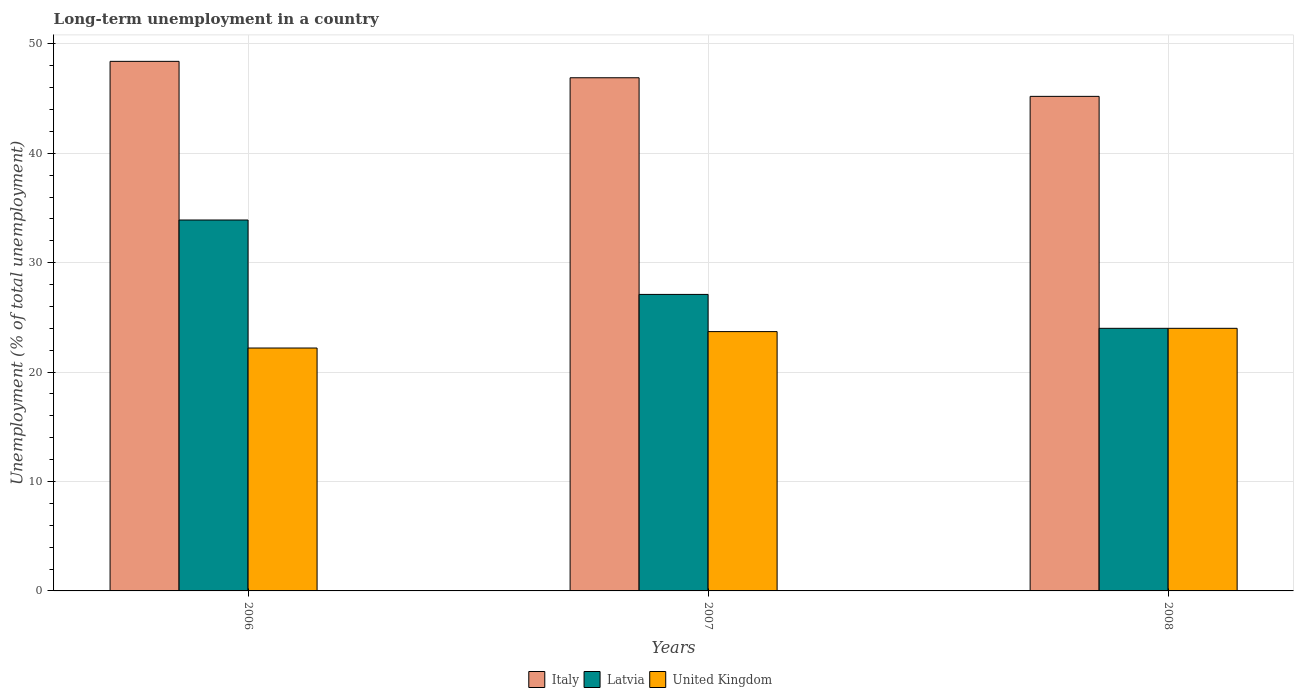How many different coloured bars are there?
Provide a short and direct response. 3. Are the number of bars on each tick of the X-axis equal?
Give a very brief answer. Yes. How many bars are there on the 2nd tick from the left?
Keep it short and to the point. 3. What is the percentage of long-term unemployed population in United Kingdom in 2006?
Provide a short and direct response. 22.2. Across all years, what is the maximum percentage of long-term unemployed population in Latvia?
Give a very brief answer. 33.9. Across all years, what is the minimum percentage of long-term unemployed population in Italy?
Ensure brevity in your answer.  45.2. In which year was the percentage of long-term unemployed population in Italy maximum?
Keep it short and to the point. 2006. What is the total percentage of long-term unemployed population in United Kingdom in the graph?
Keep it short and to the point. 69.9. What is the difference between the percentage of long-term unemployed population in Latvia in 2007 and that in 2008?
Provide a succinct answer. 3.1. What is the difference between the percentage of long-term unemployed population in United Kingdom in 2008 and the percentage of long-term unemployed population in Latvia in 2006?
Your answer should be very brief. -9.9. What is the average percentage of long-term unemployed population in United Kingdom per year?
Ensure brevity in your answer.  23.3. In the year 2008, what is the difference between the percentage of long-term unemployed population in Latvia and percentage of long-term unemployed population in United Kingdom?
Provide a short and direct response. 0. In how many years, is the percentage of long-term unemployed population in Latvia greater than 48 %?
Offer a terse response. 0. What is the ratio of the percentage of long-term unemployed population in Latvia in 2006 to that in 2008?
Provide a succinct answer. 1.41. Is the difference between the percentage of long-term unemployed population in Latvia in 2006 and 2008 greater than the difference between the percentage of long-term unemployed population in United Kingdom in 2006 and 2008?
Your answer should be very brief. Yes. What is the difference between the highest and the second highest percentage of long-term unemployed population in Italy?
Your answer should be compact. 1.5. What is the difference between the highest and the lowest percentage of long-term unemployed population in Italy?
Your answer should be compact. 3.2. In how many years, is the percentage of long-term unemployed population in United Kingdom greater than the average percentage of long-term unemployed population in United Kingdom taken over all years?
Give a very brief answer. 2. Is the sum of the percentage of long-term unemployed population in Italy in 2007 and 2008 greater than the maximum percentage of long-term unemployed population in Latvia across all years?
Ensure brevity in your answer.  Yes. What does the 3rd bar from the left in 2007 represents?
Your answer should be compact. United Kingdom. What does the 3rd bar from the right in 2006 represents?
Offer a terse response. Italy. Is it the case that in every year, the sum of the percentage of long-term unemployed population in Latvia and percentage of long-term unemployed population in Italy is greater than the percentage of long-term unemployed population in United Kingdom?
Your response must be concise. Yes. How many bars are there?
Give a very brief answer. 9. Are all the bars in the graph horizontal?
Keep it short and to the point. No. How many years are there in the graph?
Ensure brevity in your answer.  3. What is the difference between two consecutive major ticks on the Y-axis?
Give a very brief answer. 10. Are the values on the major ticks of Y-axis written in scientific E-notation?
Provide a short and direct response. No. Does the graph contain any zero values?
Your answer should be very brief. No. Does the graph contain grids?
Offer a very short reply. Yes. Where does the legend appear in the graph?
Provide a succinct answer. Bottom center. How are the legend labels stacked?
Your answer should be very brief. Horizontal. What is the title of the graph?
Offer a very short reply. Long-term unemployment in a country. Does "Angola" appear as one of the legend labels in the graph?
Make the answer very short. No. What is the label or title of the Y-axis?
Make the answer very short. Unemployment (% of total unemployment). What is the Unemployment (% of total unemployment) in Italy in 2006?
Ensure brevity in your answer.  48.4. What is the Unemployment (% of total unemployment) in Latvia in 2006?
Give a very brief answer. 33.9. What is the Unemployment (% of total unemployment) of United Kingdom in 2006?
Provide a short and direct response. 22.2. What is the Unemployment (% of total unemployment) in Italy in 2007?
Offer a terse response. 46.9. What is the Unemployment (% of total unemployment) of Latvia in 2007?
Provide a short and direct response. 27.1. What is the Unemployment (% of total unemployment) in United Kingdom in 2007?
Make the answer very short. 23.7. What is the Unemployment (% of total unemployment) in Italy in 2008?
Your answer should be very brief. 45.2. What is the Unemployment (% of total unemployment) in Latvia in 2008?
Your response must be concise. 24. Across all years, what is the maximum Unemployment (% of total unemployment) in Italy?
Ensure brevity in your answer.  48.4. Across all years, what is the maximum Unemployment (% of total unemployment) of Latvia?
Provide a short and direct response. 33.9. Across all years, what is the maximum Unemployment (% of total unemployment) of United Kingdom?
Your answer should be very brief. 24. Across all years, what is the minimum Unemployment (% of total unemployment) of Italy?
Offer a very short reply. 45.2. Across all years, what is the minimum Unemployment (% of total unemployment) of Latvia?
Give a very brief answer. 24. Across all years, what is the minimum Unemployment (% of total unemployment) in United Kingdom?
Provide a succinct answer. 22.2. What is the total Unemployment (% of total unemployment) in Italy in the graph?
Offer a terse response. 140.5. What is the total Unemployment (% of total unemployment) of Latvia in the graph?
Your answer should be very brief. 85. What is the total Unemployment (% of total unemployment) in United Kingdom in the graph?
Make the answer very short. 69.9. What is the difference between the Unemployment (% of total unemployment) in Italy in 2006 and that in 2007?
Ensure brevity in your answer.  1.5. What is the difference between the Unemployment (% of total unemployment) in Latvia in 2006 and that in 2007?
Your answer should be compact. 6.8. What is the difference between the Unemployment (% of total unemployment) of Italy in 2006 and that in 2008?
Provide a short and direct response. 3.2. What is the difference between the Unemployment (% of total unemployment) in United Kingdom in 2006 and that in 2008?
Make the answer very short. -1.8. What is the difference between the Unemployment (% of total unemployment) in United Kingdom in 2007 and that in 2008?
Offer a very short reply. -0.3. What is the difference between the Unemployment (% of total unemployment) of Italy in 2006 and the Unemployment (% of total unemployment) of Latvia in 2007?
Give a very brief answer. 21.3. What is the difference between the Unemployment (% of total unemployment) in Italy in 2006 and the Unemployment (% of total unemployment) in United Kingdom in 2007?
Give a very brief answer. 24.7. What is the difference between the Unemployment (% of total unemployment) in Italy in 2006 and the Unemployment (% of total unemployment) in Latvia in 2008?
Offer a terse response. 24.4. What is the difference between the Unemployment (% of total unemployment) in Italy in 2006 and the Unemployment (% of total unemployment) in United Kingdom in 2008?
Give a very brief answer. 24.4. What is the difference between the Unemployment (% of total unemployment) in Latvia in 2006 and the Unemployment (% of total unemployment) in United Kingdom in 2008?
Provide a succinct answer. 9.9. What is the difference between the Unemployment (% of total unemployment) in Italy in 2007 and the Unemployment (% of total unemployment) in Latvia in 2008?
Your answer should be very brief. 22.9. What is the difference between the Unemployment (% of total unemployment) in Italy in 2007 and the Unemployment (% of total unemployment) in United Kingdom in 2008?
Provide a short and direct response. 22.9. What is the difference between the Unemployment (% of total unemployment) of Latvia in 2007 and the Unemployment (% of total unemployment) of United Kingdom in 2008?
Your response must be concise. 3.1. What is the average Unemployment (% of total unemployment) of Italy per year?
Offer a very short reply. 46.83. What is the average Unemployment (% of total unemployment) in Latvia per year?
Give a very brief answer. 28.33. What is the average Unemployment (% of total unemployment) in United Kingdom per year?
Make the answer very short. 23.3. In the year 2006, what is the difference between the Unemployment (% of total unemployment) in Italy and Unemployment (% of total unemployment) in United Kingdom?
Ensure brevity in your answer.  26.2. In the year 2007, what is the difference between the Unemployment (% of total unemployment) of Italy and Unemployment (% of total unemployment) of Latvia?
Make the answer very short. 19.8. In the year 2007, what is the difference between the Unemployment (% of total unemployment) in Italy and Unemployment (% of total unemployment) in United Kingdom?
Your answer should be very brief. 23.2. In the year 2008, what is the difference between the Unemployment (% of total unemployment) of Italy and Unemployment (% of total unemployment) of Latvia?
Keep it short and to the point. 21.2. In the year 2008, what is the difference between the Unemployment (% of total unemployment) in Italy and Unemployment (% of total unemployment) in United Kingdom?
Make the answer very short. 21.2. What is the ratio of the Unemployment (% of total unemployment) of Italy in 2006 to that in 2007?
Offer a terse response. 1.03. What is the ratio of the Unemployment (% of total unemployment) in Latvia in 2006 to that in 2007?
Provide a short and direct response. 1.25. What is the ratio of the Unemployment (% of total unemployment) of United Kingdom in 2006 to that in 2007?
Keep it short and to the point. 0.94. What is the ratio of the Unemployment (% of total unemployment) in Italy in 2006 to that in 2008?
Provide a succinct answer. 1.07. What is the ratio of the Unemployment (% of total unemployment) of Latvia in 2006 to that in 2008?
Your answer should be compact. 1.41. What is the ratio of the Unemployment (% of total unemployment) of United Kingdom in 2006 to that in 2008?
Your response must be concise. 0.93. What is the ratio of the Unemployment (% of total unemployment) of Italy in 2007 to that in 2008?
Give a very brief answer. 1.04. What is the ratio of the Unemployment (% of total unemployment) of Latvia in 2007 to that in 2008?
Provide a short and direct response. 1.13. What is the ratio of the Unemployment (% of total unemployment) in United Kingdom in 2007 to that in 2008?
Offer a terse response. 0.99. What is the difference between the highest and the second highest Unemployment (% of total unemployment) of Italy?
Ensure brevity in your answer.  1.5. What is the difference between the highest and the second highest Unemployment (% of total unemployment) of Latvia?
Ensure brevity in your answer.  6.8. What is the difference between the highest and the second highest Unemployment (% of total unemployment) of United Kingdom?
Offer a terse response. 0.3. What is the difference between the highest and the lowest Unemployment (% of total unemployment) in Italy?
Provide a succinct answer. 3.2. What is the difference between the highest and the lowest Unemployment (% of total unemployment) of United Kingdom?
Keep it short and to the point. 1.8. 